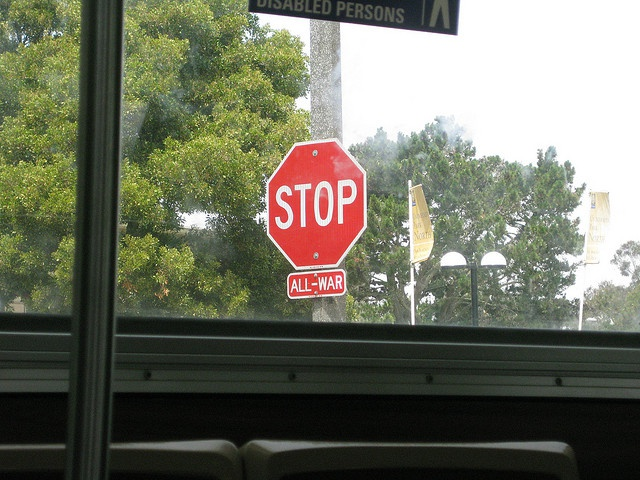Describe the objects in this image and their specific colors. I can see a stop sign in teal, red, and white tones in this image. 